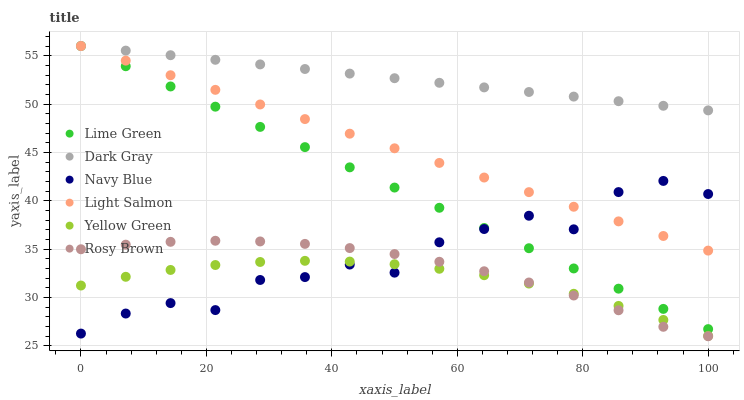Does Yellow Green have the minimum area under the curve?
Answer yes or no. Yes. Does Dark Gray have the maximum area under the curve?
Answer yes or no. Yes. Does Navy Blue have the minimum area under the curve?
Answer yes or no. No. Does Navy Blue have the maximum area under the curve?
Answer yes or no. No. Is Dark Gray the smoothest?
Answer yes or no. Yes. Is Navy Blue the roughest?
Answer yes or no. Yes. Is Yellow Green the smoothest?
Answer yes or no. No. Is Yellow Green the roughest?
Answer yes or no. No. Does Rosy Brown have the lowest value?
Answer yes or no. Yes. Does Yellow Green have the lowest value?
Answer yes or no. No. Does Lime Green have the highest value?
Answer yes or no. Yes. Does Navy Blue have the highest value?
Answer yes or no. No. Is Navy Blue less than Dark Gray?
Answer yes or no. Yes. Is Lime Green greater than Rosy Brown?
Answer yes or no. Yes. Does Lime Green intersect Dark Gray?
Answer yes or no. Yes. Is Lime Green less than Dark Gray?
Answer yes or no. No. Is Lime Green greater than Dark Gray?
Answer yes or no. No. Does Navy Blue intersect Dark Gray?
Answer yes or no. No. 